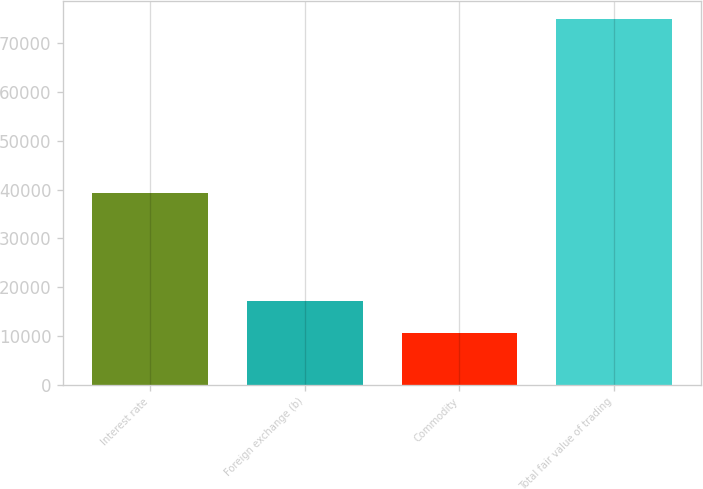Convert chart to OTSL. <chart><loc_0><loc_0><loc_500><loc_500><bar_chart><fcel>Interest rate<fcel>Foreign exchange (b)<fcel>Commodity<fcel>Total fair value of trading<nl><fcel>39205<fcel>17069.8<fcel>10635<fcel>74983<nl></chart> 